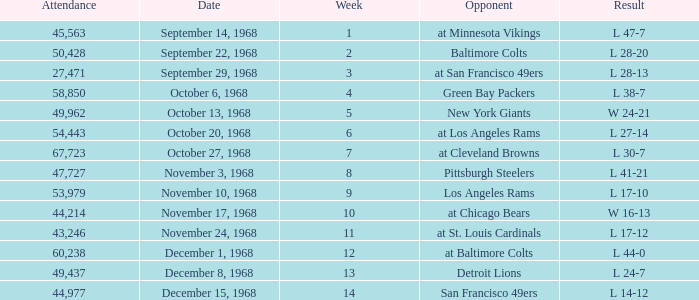Which Attendance has an Opponent of new york giants, and a Week smaller than 5? None. 